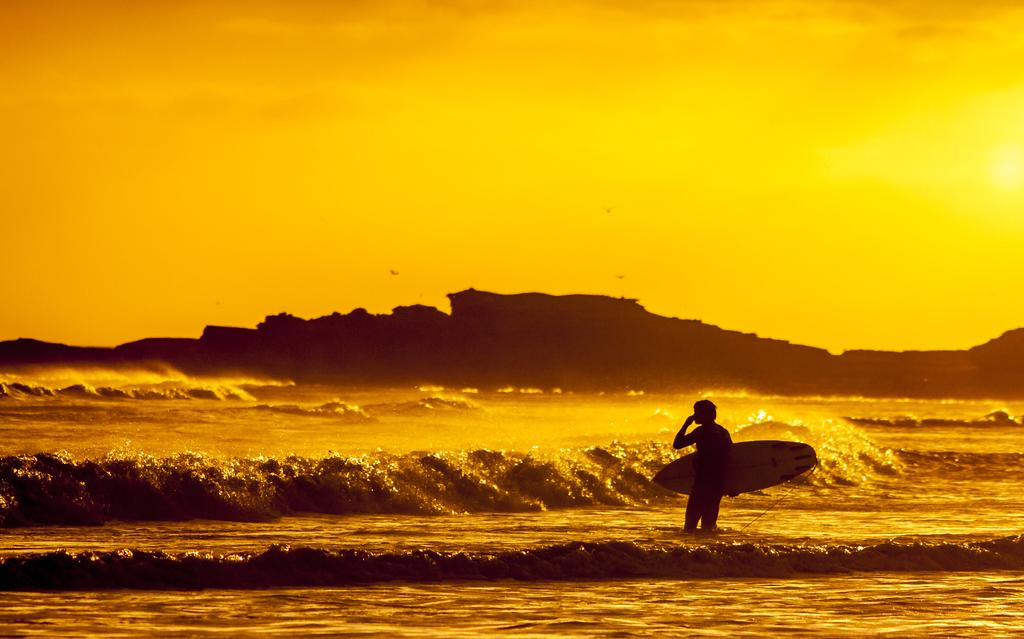What is the main subject of the image? The main subject of the image is a man. What is the man holding in the image? The man is holding a surf boat in the image. Where is the man located in the image? The man is standing in the water in the image. What can be seen in the background of the image? There is sky, hills, and sea visible in the background of the image. How many farmers are visible in the image? There are no farmers present in the image; it features a man holding a surf boat and standing in the water. What is the size of the smoke coming from the chimney in the image? There is no smoke or chimney present in the image. 